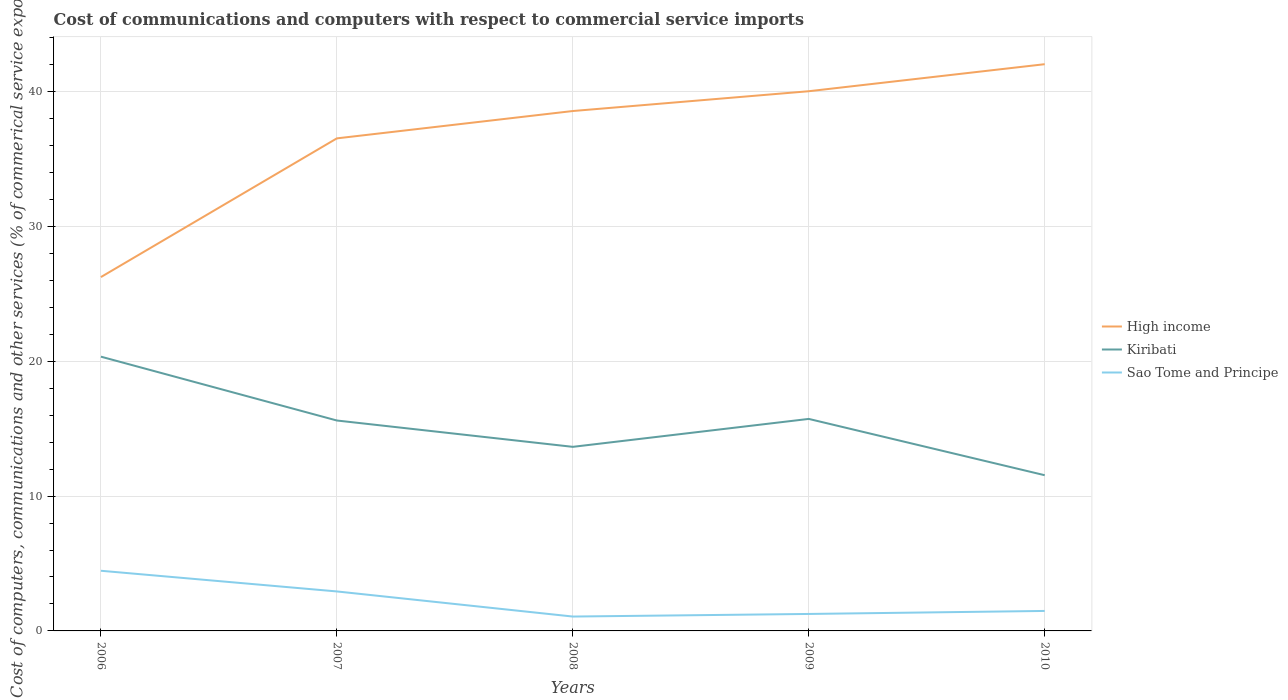Across all years, what is the maximum cost of communications and computers in High income?
Your response must be concise. 26.24. In which year was the cost of communications and computers in Kiribati maximum?
Keep it short and to the point. 2010. What is the total cost of communications and computers in High income in the graph?
Your answer should be compact. -3.5. What is the difference between the highest and the second highest cost of communications and computers in High income?
Ensure brevity in your answer.  15.79. What is the difference between the highest and the lowest cost of communications and computers in Kiribati?
Provide a short and direct response. 3. How many lines are there?
Offer a terse response. 3. What is the difference between two consecutive major ticks on the Y-axis?
Ensure brevity in your answer.  10. How are the legend labels stacked?
Offer a terse response. Vertical. What is the title of the graph?
Give a very brief answer. Cost of communications and computers with respect to commercial service imports. Does "Grenada" appear as one of the legend labels in the graph?
Provide a short and direct response. No. What is the label or title of the Y-axis?
Your answer should be compact. Cost of computers, communications and other services (% of commerical service exports). What is the Cost of computers, communications and other services (% of commerical service exports) of High income in 2006?
Give a very brief answer. 26.24. What is the Cost of computers, communications and other services (% of commerical service exports) in Kiribati in 2006?
Ensure brevity in your answer.  20.34. What is the Cost of computers, communications and other services (% of commerical service exports) in Sao Tome and Principe in 2006?
Ensure brevity in your answer.  4.46. What is the Cost of computers, communications and other services (% of commerical service exports) in High income in 2007?
Your answer should be compact. 36.52. What is the Cost of computers, communications and other services (% of commerical service exports) in Kiribati in 2007?
Make the answer very short. 15.6. What is the Cost of computers, communications and other services (% of commerical service exports) in Sao Tome and Principe in 2007?
Keep it short and to the point. 2.93. What is the Cost of computers, communications and other services (% of commerical service exports) in High income in 2008?
Give a very brief answer. 38.55. What is the Cost of computers, communications and other services (% of commerical service exports) of Kiribati in 2008?
Your response must be concise. 13.65. What is the Cost of computers, communications and other services (% of commerical service exports) in Sao Tome and Principe in 2008?
Your response must be concise. 1.07. What is the Cost of computers, communications and other services (% of commerical service exports) in High income in 2009?
Provide a succinct answer. 40.02. What is the Cost of computers, communications and other services (% of commerical service exports) of Kiribati in 2009?
Your response must be concise. 15.72. What is the Cost of computers, communications and other services (% of commerical service exports) of Sao Tome and Principe in 2009?
Provide a short and direct response. 1.26. What is the Cost of computers, communications and other services (% of commerical service exports) of High income in 2010?
Provide a short and direct response. 42.02. What is the Cost of computers, communications and other services (% of commerical service exports) of Kiribati in 2010?
Your answer should be compact. 11.55. What is the Cost of computers, communications and other services (% of commerical service exports) of Sao Tome and Principe in 2010?
Keep it short and to the point. 1.48. Across all years, what is the maximum Cost of computers, communications and other services (% of commerical service exports) in High income?
Offer a very short reply. 42.02. Across all years, what is the maximum Cost of computers, communications and other services (% of commerical service exports) in Kiribati?
Make the answer very short. 20.34. Across all years, what is the maximum Cost of computers, communications and other services (% of commerical service exports) of Sao Tome and Principe?
Your response must be concise. 4.46. Across all years, what is the minimum Cost of computers, communications and other services (% of commerical service exports) of High income?
Provide a succinct answer. 26.24. Across all years, what is the minimum Cost of computers, communications and other services (% of commerical service exports) of Kiribati?
Your response must be concise. 11.55. Across all years, what is the minimum Cost of computers, communications and other services (% of commerical service exports) of Sao Tome and Principe?
Ensure brevity in your answer.  1.07. What is the total Cost of computers, communications and other services (% of commerical service exports) in High income in the graph?
Make the answer very short. 183.36. What is the total Cost of computers, communications and other services (% of commerical service exports) in Kiribati in the graph?
Provide a succinct answer. 76.86. What is the total Cost of computers, communications and other services (% of commerical service exports) of Sao Tome and Principe in the graph?
Give a very brief answer. 11.2. What is the difference between the Cost of computers, communications and other services (% of commerical service exports) in High income in 2006 and that in 2007?
Your response must be concise. -10.29. What is the difference between the Cost of computers, communications and other services (% of commerical service exports) of Kiribati in 2006 and that in 2007?
Your answer should be compact. 4.73. What is the difference between the Cost of computers, communications and other services (% of commerical service exports) in Sao Tome and Principe in 2006 and that in 2007?
Offer a very short reply. 1.53. What is the difference between the Cost of computers, communications and other services (% of commerical service exports) of High income in 2006 and that in 2008?
Provide a short and direct response. -12.31. What is the difference between the Cost of computers, communications and other services (% of commerical service exports) in Kiribati in 2006 and that in 2008?
Your answer should be very brief. 6.69. What is the difference between the Cost of computers, communications and other services (% of commerical service exports) of Sao Tome and Principe in 2006 and that in 2008?
Your answer should be compact. 3.4. What is the difference between the Cost of computers, communications and other services (% of commerical service exports) of High income in 2006 and that in 2009?
Your answer should be compact. -13.78. What is the difference between the Cost of computers, communications and other services (% of commerical service exports) of Kiribati in 2006 and that in 2009?
Provide a short and direct response. 4.62. What is the difference between the Cost of computers, communications and other services (% of commerical service exports) in Sao Tome and Principe in 2006 and that in 2009?
Ensure brevity in your answer.  3.2. What is the difference between the Cost of computers, communications and other services (% of commerical service exports) of High income in 2006 and that in 2010?
Offer a terse response. -15.79. What is the difference between the Cost of computers, communications and other services (% of commerical service exports) of Kiribati in 2006 and that in 2010?
Provide a succinct answer. 8.79. What is the difference between the Cost of computers, communications and other services (% of commerical service exports) in Sao Tome and Principe in 2006 and that in 2010?
Ensure brevity in your answer.  2.98. What is the difference between the Cost of computers, communications and other services (% of commerical service exports) of High income in 2007 and that in 2008?
Your answer should be compact. -2.03. What is the difference between the Cost of computers, communications and other services (% of commerical service exports) of Kiribati in 2007 and that in 2008?
Your response must be concise. 1.95. What is the difference between the Cost of computers, communications and other services (% of commerical service exports) in Sao Tome and Principe in 2007 and that in 2008?
Provide a succinct answer. 1.86. What is the difference between the Cost of computers, communications and other services (% of commerical service exports) of High income in 2007 and that in 2009?
Make the answer very short. -3.5. What is the difference between the Cost of computers, communications and other services (% of commerical service exports) in Kiribati in 2007 and that in 2009?
Make the answer very short. -0.12. What is the difference between the Cost of computers, communications and other services (% of commerical service exports) of Sao Tome and Principe in 2007 and that in 2009?
Keep it short and to the point. 1.67. What is the difference between the Cost of computers, communications and other services (% of commerical service exports) in High income in 2007 and that in 2010?
Your answer should be compact. -5.5. What is the difference between the Cost of computers, communications and other services (% of commerical service exports) in Kiribati in 2007 and that in 2010?
Your answer should be compact. 4.06. What is the difference between the Cost of computers, communications and other services (% of commerical service exports) in Sao Tome and Principe in 2007 and that in 2010?
Provide a short and direct response. 1.45. What is the difference between the Cost of computers, communications and other services (% of commerical service exports) of High income in 2008 and that in 2009?
Make the answer very short. -1.47. What is the difference between the Cost of computers, communications and other services (% of commerical service exports) of Kiribati in 2008 and that in 2009?
Provide a short and direct response. -2.07. What is the difference between the Cost of computers, communications and other services (% of commerical service exports) in Sao Tome and Principe in 2008 and that in 2009?
Give a very brief answer. -0.19. What is the difference between the Cost of computers, communications and other services (% of commerical service exports) in High income in 2008 and that in 2010?
Your answer should be very brief. -3.47. What is the difference between the Cost of computers, communications and other services (% of commerical service exports) of Kiribati in 2008 and that in 2010?
Provide a short and direct response. 2.1. What is the difference between the Cost of computers, communications and other services (% of commerical service exports) in Sao Tome and Principe in 2008 and that in 2010?
Provide a short and direct response. -0.42. What is the difference between the Cost of computers, communications and other services (% of commerical service exports) in High income in 2009 and that in 2010?
Your response must be concise. -2. What is the difference between the Cost of computers, communications and other services (% of commerical service exports) in Kiribati in 2009 and that in 2010?
Provide a succinct answer. 4.18. What is the difference between the Cost of computers, communications and other services (% of commerical service exports) in Sao Tome and Principe in 2009 and that in 2010?
Your response must be concise. -0.22. What is the difference between the Cost of computers, communications and other services (% of commerical service exports) in High income in 2006 and the Cost of computers, communications and other services (% of commerical service exports) in Kiribati in 2007?
Keep it short and to the point. 10.64. What is the difference between the Cost of computers, communications and other services (% of commerical service exports) of High income in 2006 and the Cost of computers, communications and other services (% of commerical service exports) of Sao Tome and Principe in 2007?
Provide a succinct answer. 23.31. What is the difference between the Cost of computers, communications and other services (% of commerical service exports) of Kiribati in 2006 and the Cost of computers, communications and other services (% of commerical service exports) of Sao Tome and Principe in 2007?
Give a very brief answer. 17.41. What is the difference between the Cost of computers, communications and other services (% of commerical service exports) in High income in 2006 and the Cost of computers, communications and other services (% of commerical service exports) in Kiribati in 2008?
Keep it short and to the point. 12.59. What is the difference between the Cost of computers, communications and other services (% of commerical service exports) of High income in 2006 and the Cost of computers, communications and other services (% of commerical service exports) of Sao Tome and Principe in 2008?
Provide a short and direct response. 25.17. What is the difference between the Cost of computers, communications and other services (% of commerical service exports) in Kiribati in 2006 and the Cost of computers, communications and other services (% of commerical service exports) in Sao Tome and Principe in 2008?
Give a very brief answer. 19.27. What is the difference between the Cost of computers, communications and other services (% of commerical service exports) of High income in 2006 and the Cost of computers, communications and other services (% of commerical service exports) of Kiribati in 2009?
Provide a succinct answer. 10.52. What is the difference between the Cost of computers, communications and other services (% of commerical service exports) of High income in 2006 and the Cost of computers, communications and other services (% of commerical service exports) of Sao Tome and Principe in 2009?
Offer a terse response. 24.98. What is the difference between the Cost of computers, communications and other services (% of commerical service exports) of Kiribati in 2006 and the Cost of computers, communications and other services (% of commerical service exports) of Sao Tome and Principe in 2009?
Offer a terse response. 19.08. What is the difference between the Cost of computers, communications and other services (% of commerical service exports) in High income in 2006 and the Cost of computers, communications and other services (% of commerical service exports) in Kiribati in 2010?
Your response must be concise. 14.69. What is the difference between the Cost of computers, communications and other services (% of commerical service exports) of High income in 2006 and the Cost of computers, communications and other services (% of commerical service exports) of Sao Tome and Principe in 2010?
Provide a short and direct response. 24.76. What is the difference between the Cost of computers, communications and other services (% of commerical service exports) in Kiribati in 2006 and the Cost of computers, communications and other services (% of commerical service exports) in Sao Tome and Principe in 2010?
Your answer should be very brief. 18.85. What is the difference between the Cost of computers, communications and other services (% of commerical service exports) of High income in 2007 and the Cost of computers, communications and other services (% of commerical service exports) of Kiribati in 2008?
Ensure brevity in your answer.  22.87. What is the difference between the Cost of computers, communications and other services (% of commerical service exports) of High income in 2007 and the Cost of computers, communications and other services (% of commerical service exports) of Sao Tome and Principe in 2008?
Give a very brief answer. 35.46. What is the difference between the Cost of computers, communications and other services (% of commerical service exports) of Kiribati in 2007 and the Cost of computers, communications and other services (% of commerical service exports) of Sao Tome and Principe in 2008?
Offer a very short reply. 14.54. What is the difference between the Cost of computers, communications and other services (% of commerical service exports) of High income in 2007 and the Cost of computers, communications and other services (% of commerical service exports) of Kiribati in 2009?
Your answer should be compact. 20.8. What is the difference between the Cost of computers, communications and other services (% of commerical service exports) in High income in 2007 and the Cost of computers, communications and other services (% of commerical service exports) in Sao Tome and Principe in 2009?
Offer a very short reply. 35.27. What is the difference between the Cost of computers, communications and other services (% of commerical service exports) of Kiribati in 2007 and the Cost of computers, communications and other services (% of commerical service exports) of Sao Tome and Principe in 2009?
Provide a short and direct response. 14.34. What is the difference between the Cost of computers, communications and other services (% of commerical service exports) of High income in 2007 and the Cost of computers, communications and other services (% of commerical service exports) of Kiribati in 2010?
Your answer should be very brief. 24.98. What is the difference between the Cost of computers, communications and other services (% of commerical service exports) in High income in 2007 and the Cost of computers, communications and other services (% of commerical service exports) in Sao Tome and Principe in 2010?
Your answer should be very brief. 35.04. What is the difference between the Cost of computers, communications and other services (% of commerical service exports) in Kiribati in 2007 and the Cost of computers, communications and other services (% of commerical service exports) in Sao Tome and Principe in 2010?
Provide a succinct answer. 14.12. What is the difference between the Cost of computers, communications and other services (% of commerical service exports) of High income in 2008 and the Cost of computers, communications and other services (% of commerical service exports) of Kiribati in 2009?
Give a very brief answer. 22.83. What is the difference between the Cost of computers, communications and other services (% of commerical service exports) of High income in 2008 and the Cost of computers, communications and other services (% of commerical service exports) of Sao Tome and Principe in 2009?
Your answer should be very brief. 37.29. What is the difference between the Cost of computers, communications and other services (% of commerical service exports) of Kiribati in 2008 and the Cost of computers, communications and other services (% of commerical service exports) of Sao Tome and Principe in 2009?
Give a very brief answer. 12.39. What is the difference between the Cost of computers, communications and other services (% of commerical service exports) in High income in 2008 and the Cost of computers, communications and other services (% of commerical service exports) in Kiribati in 2010?
Your answer should be very brief. 27.01. What is the difference between the Cost of computers, communications and other services (% of commerical service exports) in High income in 2008 and the Cost of computers, communications and other services (% of commerical service exports) in Sao Tome and Principe in 2010?
Provide a succinct answer. 37.07. What is the difference between the Cost of computers, communications and other services (% of commerical service exports) of Kiribati in 2008 and the Cost of computers, communications and other services (% of commerical service exports) of Sao Tome and Principe in 2010?
Your answer should be very brief. 12.17. What is the difference between the Cost of computers, communications and other services (% of commerical service exports) in High income in 2009 and the Cost of computers, communications and other services (% of commerical service exports) in Kiribati in 2010?
Provide a short and direct response. 28.47. What is the difference between the Cost of computers, communications and other services (% of commerical service exports) of High income in 2009 and the Cost of computers, communications and other services (% of commerical service exports) of Sao Tome and Principe in 2010?
Offer a terse response. 38.54. What is the difference between the Cost of computers, communications and other services (% of commerical service exports) of Kiribati in 2009 and the Cost of computers, communications and other services (% of commerical service exports) of Sao Tome and Principe in 2010?
Ensure brevity in your answer.  14.24. What is the average Cost of computers, communications and other services (% of commerical service exports) of High income per year?
Make the answer very short. 36.67. What is the average Cost of computers, communications and other services (% of commerical service exports) in Kiribati per year?
Provide a short and direct response. 15.37. What is the average Cost of computers, communications and other services (% of commerical service exports) of Sao Tome and Principe per year?
Offer a terse response. 2.24. In the year 2006, what is the difference between the Cost of computers, communications and other services (% of commerical service exports) of High income and Cost of computers, communications and other services (% of commerical service exports) of Kiribati?
Provide a short and direct response. 5.9. In the year 2006, what is the difference between the Cost of computers, communications and other services (% of commerical service exports) of High income and Cost of computers, communications and other services (% of commerical service exports) of Sao Tome and Principe?
Keep it short and to the point. 21.78. In the year 2006, what is the difference between the Cost of computers, communications and other services (% of commerical service exports) of Kiribati and Cost of computers, communications and other services (% of commerical service exports) of Sao Tome and Principe?
Ensure brevity in your answer.  15.88. In the year 2007, what is the difference between the Cost of computers, communications and other services (% of commerical service exports) of High income and Cost of computers, communications and other services (% of commerical service exports) of Kiribati?
Provide a short and direct response. 20.92. In the year 2007, what is the difference between the Cost of computers, communications and other services (% of commerical service exports) of High income and Cost of computers, communications and other services (% of commerical service exports) of Sao Tome and Principe?
Your answer should be compact. 33.6. In the year 2007, what is the difference between the Cost of computers, communications and other services (% of commerical service exports) in Kiribati and Cost of computers, communications and other services (% of commerical service exports) in Sao Tome and Principe?
Ensure brevity in your answer.  12.67. In the year 2008, what is the difference between the Cost of computers, communications and other services (% of commerical service exports) of High income and Cost of computers, communications and other services (% of commerical service exports) of Kiribati?
Your response must be concise. 24.9. In the year 2008, what is the difference between the Cost of computers, communications and other services (% of commerical service exports) of High income and Cost of computers, communications and other services (% of commerical service exports) of Sao Tome and Principe?
Give a very brief answer. 37.49. In the year 2008, what is the difference between the Cost of computers, communications and other services (% of commerical service exports) in Kiribati and Cost of computers, communications and other services (% of commerical service exports) in Sao Tome and Principe?
Provide a succinct answer. 12.58. In the year 2009, what is the difference between the Cost of computers, communications and other services (% of commerical service exports) in High income and Cost of computers, communications and other services (% of commerical service exports) in Kiribati?
Give a very brief answer. 24.3. In the year 2009, what is the difference between the Cost of computers, communications and other services (% of commerical service exports) of High income and Cost of computers, communications and other services (% of commerical service exports) of Sao Tome and Principe?
Keep it short and to the point. 38.76. In the year 2009, what is the difference between the Cost of computers, communications and other services (% of commerical service exports) of Kiribati and Cost of computers, communications and other services (% of commerical service exports) of Sao Tome and Principe?
Provide a short and direct response. 14.46. In the year 2010, what is the difference between the Cost of computers, communications and other services (% of commerical service exports) of High income and Cost of computers, communications and other services (% of commerical service exports) of Kiribati?
Provide a succinct answer. 30.48. In the year 2010, what is the difference between the Cost of computers, communications and other services (% of commerical service exports) of High income and Cost of computers, communications and other services (% of commerical service exports) of Sao Tome and Principe?
Make the answer very short. 40.54. In the year 2010, what is the difference between the Cost of computers, communications and other services (% of commerical service exports) in Kiribati and Cost of computers, communications and other services (% of commerical service exports) in Sao Tome and Principe?
Offer a terse response. 10.06. What is the ratio of the Cost of computers, communications and other services (% of commerical service exports) of High income in 2006 to that in 2007?
Your answer should be compact. 0.72. What is the ratio of the Cost of computers, communications and other services (% of commerical service exports) in Kiribati in 2006 to that in 2007?
Your answer should be compact. 1.3. What is the ratio of the Cost of computers, communications and other services (% of commerical service exports) of Sao Tome and Principe in 2006 to that in 2007?
Make the answer very short. 1.52. What is the ratio of the Cost of computers, communications and other services (% of commerical service exports) in High income in 2006 to that in 2008?
Your answer should be very brief. 0.68. What is the ratio of the Cost of computers, communications and other services (% of commerical service exports) of Kiribati in 2006 to that in 2008?
Your answer should be compact. 1.49. What is the ratio of the Cost of computers, communications and other services (% of commerical service exports) in Sao Tome and Principe in 2006 to that in 2008?
Give a very brief answer. 4.19. What is the ratio of the Cost of computers, communications and other services (% of commerical service exports) in High income in 2006 to that in 2009?
Make the answer very short. 0.66. What is the ratio of the Cost of computers, communications and other services (% of commerical service exports) of Kiribati in 2006 to that in 2009?
Give a very brief answer. 1.29. What is the ratio of the Cost of computers, communications and other services (% of commerical service exports) in Sao Tome and Principe in 2006 to that in 2009?
Give a very brief answer. 3.55. What is the ratio of the Cost of computers, communications and other services (% of commerical service exports) of High income in 2006 to that in 2010?
Your answer should be compact. 0.62. What is the ratio of the Cost of computers, communications and other services (% of commerical service exports) of Kiribati in 2006 to that in 2010?
Provide a short and direct response. 1.76. What is the ratio of the Cost of computers, communications and other services (% of commerical service exports) of Sao Tome and Principe in 2006 to that in 2010?
Provide a succinct answer. 3.01. What is the ratio of the Cost of computers, communications and other services (% of commerical service exports) in High income in 2007 to that in 2008?
Your answer should be very brief. 0.95. What is the ratio of the Cost of computers, communications and other services (% of commerical service exports) in Kiribati in 2007 to that in 2008?
Provide a succinct answer. 1.14. What is the ratio of the Cost of computers, communications and other services (% of commerical service exports) of Sao Tome and Principe in 2007 to that in 2008?
Provide a short and direct response. 2.75. What is the ratio of the Cost of computers, communications and other services (% of commerical service exports) of High income in 2007 to that in 2009?
Your response must be concise. 0.91. What is the ratio of the Cost of computers, communications and other services (% of commerical service exports) in Sao Tome and Principe in 2007 to that in 2009?
Keep it short and to the point. 2.33. What is the ratio of the Cost of computers, communications and other services (% of commerical service exports) in High income in 2007 to that in 2010?
Your response must be concise. 0.87. What is the ratio of the Cost of computers, communications and other services (% of commerical service exports) in Kiribati in 2007 to that in 2010?
Your answer should be compact. 1.35. What is the ratio of the Cost of computers, communications and other services (% of commerical service exports) in Sao Tome and Principe in 2007 to that in 2010?
Provide a short and direct response. 1.98. What is the ratio of the Cost of computers, communications and other services (% of commerical service exports) in High income in 2008 to that in 2009?
Your response must be concise. 0.96. What is the ratio of the Cost of computers, communications and other services (% of commerical service exports) in Kiribati in 2008 to that in 2009?
Your answer should be compact. 0.87. What is the ratio of the Cost of computers, communications and other services (% of commerical service exports) of Sao Tome and Principe in 2008 to that in 2009?
Offer a terse response. 0.85. What is the ratio of the Cost of computers, communications and other services (% of commerical service exports) of High income in 2008 to that in 2010?
Ensure brevity in your answer.  0.92. What is the ratio of the Cost of computers, communications and other services (% of commerical service exports) in Kiribati in 2008 to that in 2010?
Make the answer very short. 1.18. What is the ratio of the Cost of computers, communications and other services (% of commerical service exports) in Sao Tome and Principe in 2008 to that in 2010?
Offer a terse response. 0.72. What is the ratio of the Cost of computers, communications and other services (% of commerical service exports) in High income in 2009 to that in 2010?
Offer a very short reply. 0.95. What is the ratio of the Cost of computers, communications and other services (% of commerical service exports) in Kiribati in 2009 to that in 2010?
Offer a terse response. 1.36. What is the ratio of the Cost of computers, communications and other services (% of commerical service exports) of Sao Tome and Principe in 2009 to that in 2010?
Provide a short and direct response. 0.85. What is the difference between the highest and the second highest Cost of computers, communications and other services (% of commerical service exports) in High income?
Give a very brief answer. 2. What is the difference between the highest and the second highest Cost of computers, communications and other services (% of commerical service exports) in Kiribati?
Provide a succinct answer. 4.62. What is the difference between the highest and the second highest Cost of computers, communications and other services (% of commerical service exports) of Sao Tome and Principe?
Your answer should be very brief. 1.53. What is the difference between the highest and the lowest Cost of computers, communications and other services (% of commerical service exports) in High income?
Your answer should be compact. 15.79. What is the difference between the highest and the lowest Cost of computers, communications and other services (% of commerical service exports) of Kiribati?
Your answer should be very brief. 8.79. What is the difference between the highest and the lowest Cost of computers, communications and other services (% of commerical service exports) of Sao Tome and Principe?
Provide a succinct answer. 3.4. 